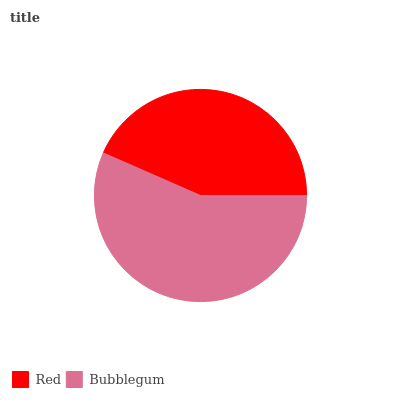Is Red the minimum?
Answer yes or no. Yes. Is Bubblegum the maximum?
Answer yes or no. Yes. Is Bubblegum the minimum?
Answer yes or no. No. Is Bubblegum greater than Red?
Answer yes or no. Yes. Is Red less than Bubblegum?
Answer yes or no. Yes. Is Red greater than Bubblegum?
Answer yes or no. No. Is Bubblegum less than Red?
Answer yes or no. No. Is Bubblegum the high median?
Answer yes or no. Yes. Is Red the low median?
Answer yes or no. Yes. Is Red the high median?
Answer yes or no. No. Is Bubblegum the low median?
Answer yes or no. No. 